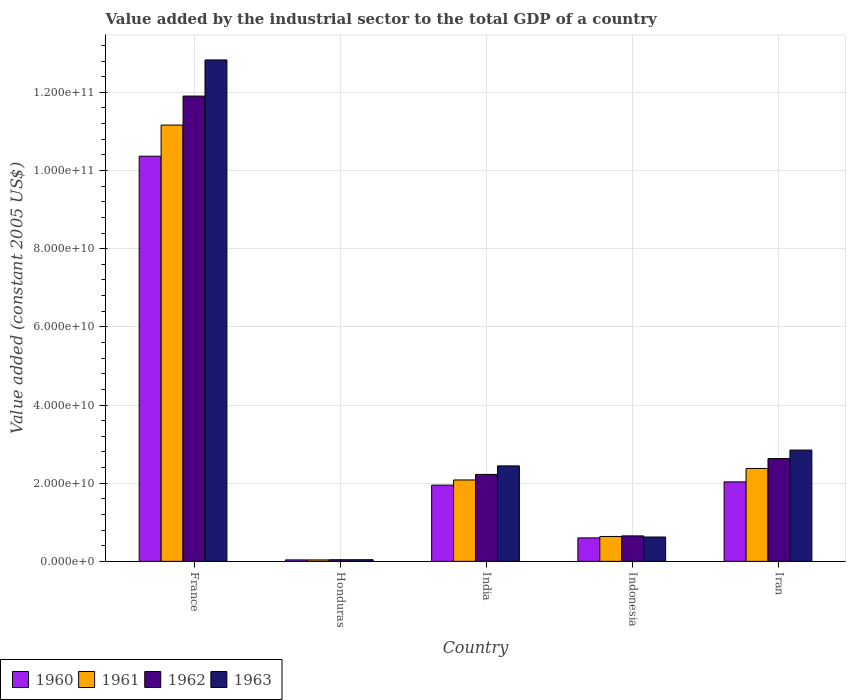How many bars are there on the 3rd tick from the left?
Your answer should be very brief. 4. What is the value added by the industrial sector in 1960 in Honduras?
Provide a short and direct response. 3.75e+08. Across all countries, what is the maximum value added by the industrial sector in 1963?
Provide a short and direct response. 1.28e+11. Across all countries, what is the minimum value added by the industrial sector in 1962?
Provide a short and direct response. 4.16e+08. In which country was the value added by the industrial sector in 1960 minimum?
Offer a very short reply. Honduras. What is the total value added by the industrial sector in 1961 in the graph?
Provide a short and direct response. 1.63e+11. What is the difference between the value added by the industrial sector in 1960 in Honduras and that in Iran?
Keep it short and to the point. -2.00e+1. What is the difference between the value added by the industrial sector in 1963 in Honduras and the value added by the industrial sector in 1960 in Indonesia?
Offer a very short reply. -5.58e+09. What is the average value added by the industrial sector in 1962 per country?
Give a very brief answer. 3.49e+1. What is the difference between the value added by the industrial sector of/in 1960 and value added by the industrial sector of/in 1962 in Iran?
Provide a succinct answer. -5.96e+09. In how many countries, is the value added by the industrial sector in 1960 greater than 12000000000 US$?
Keep it short and to the point. 3. What is the ratio of the value added by the industrial sector in 1961 in Honduras to that in India?
Your answer should be very brief. 0.02. Is the difference between the value added by the industrial sector in 1960 in India and Iran greater than the difference between the value added by the industrial sector in 1962 in India and Iran?
Offer a very short reply. Yes. What is the difference between the highest and the second highest value added by the industrial sector in 1960?
Your response must be concise. 8.33e+1. What is the difference between the highest and the lowest value added by the industrial sector in 1961?
Offer a terse response. 1.11e+11. Is the sum of the value added by the industrial sector in 1961 in France and Honduras greater than the maximum value added by the industrial sector in 1962 across all countries?
Your answer should be very brief. No. Is it the case that in every country, the sum of the value added by the industrial sector in 1960 and value added by the industrial sector in 1963 is greater than the value added by the industrial sector in 1962?
Your response must be concise. Yes. How many bars are there?
Give a very brief answer. 20. What is the difference between two consecutive major ticks on the Y-axis?
Ensure brevity in your answer.  2.00e+1. Does the graph contain any zero values?
Provide a succinct answer. No. Where does the legend appear in the graph?
Offer a terse response. Bottom left. How many legend labels are there?
Provide a succinct answer. 4. What is the title of the graph?
Your answer should be very brief. Value added by the industrial sector to the total GDP of a country. Does "1981" appear as one of the legend labels in the graph?
Make the answer very short. No. What is the label or title of the X-axis?
Offer a terse response. Country. What is the label or title of the Y-axis?
Keep it short and to the point. Value added (constant 2005 US$). What is the Value added (constant 2005 US$) in 1960 in France?
Make the answer very short. 1.04e+11. What is the Value added (constant 2005 US$) in 1961 in France?
Your response must be concise. 1.12e+11. What is the Value added (constant 2005 US$) in 1962 in France?
Provide a succinct answer. 1.19e+11. What is the Value added (constant 2005 US$) in 1963 in France?
Make the answer very short. 1.28e+11. What is the Value added (constant 2005 US$) of 1960 in Honduras?
Ensure brevity in your answer.  3.75e+08. What is the Value added (constant 2005 US$) in 1961 in Honduras?
Your response must be concise. 3.66e+08. What is the Value added (constant 2005 US$) of 1962 in Honduras?
Keep it short and to the point. 4.16e+08. What is the Value added (constant 2005 US$) in 1963 in Honduras?
Provide a succinct answer. 4.23e+08. What is the Value added (constant 2005 US$) in 1960 in India?
Provide a succinct answer. 1.95e+1. What is the Value added (constant 2005 US$) of 1961 in India?
Your answer should be very brief. 2.08e+1. What is the Value added (constant 2005 US$) in 1962 in India?
Your response must be concise. 2.22e+1. What is the Value added (constant 2005 US$) of 1963 in India?
Your answer should be compact. 2.44e+1. What is the Value added (constant 2005 US$) in 1960 in Indonesia?
Your response must be concise. 6.01e+09. What is the Value added (constant 2005 US$) in 1961 in Indonesia?
Provide a short and direct response. 6.37e+09. What is the Value added (constant 2005 US$) in 1962 in Indonesia?
Give a very brief answer. 6.52e+09. What is the Value added (constant 2005 US$) in 1963 in Indonesia?
Ensure brevity in your answer.  6.23e+09. What is the Value added (constant 2005 US$) of 1960 in Iran?
Offer a terse response. 2.03e+1. What is the Value added (constant 2005 US$) of 1961 in Iran?
Your answer should be compact. 2.38e+1. What is the Value added (constant 2005 US$) in 1962 in Iran?
Keep it short and to the point. 2.63e+1. What is the Value added (constant 2005 US$) of 1963 in Iran?
Keep it short and to the point. 2.85e+1. Across all countries, what is the maximum Value added (constant 2005 US$) of 1960?
Ensure brevity in your answer.  1.04e+11. Across all countries, what is the maximum Value added (constant 2005 US$) of 1961?
Provide a succinct answer. 1.12e+11. Across all countries, what is the maximum Value added (constant 2005 US$) in 1962?
Offer a terse response. 1.19e+11. Across all countries, what is the maximum Value added (constant 2005 US$) in 1963?
Give a very brief answer. 1.28e+11. Across all countries, what is the minimum Value added (constant 2005 US$) in 1960?
Your answer should be very brief. 3.75e+08. Across all countries, what is the minimum Value added (constant 2005 US$) of 1961?
Provide a succinct answer. 3.66e+08. Across all countries, what is the minimum Value added (constant 2005 US$) of 1962?
Offer a very short reply. 4.16e+08. Across all countries, what is the minimum Value added (constant 2005 US$) of 1963?
Your answer should be very brief. 4.23e+08. What is the total Value added (constant 2005 US$) in 1960 in the graph?
Make the answer very short. 1.50e+11. What is the total Value added (constant 2005 US$) in 1961 in the graph?
Ensure brevity in your answer.  1.63e+11. What is the total Value added (constant 2005 US$) of 1962 in the graph?
Provide a short and direct response. 1.75e+11. What is the total Value added (constant 2005 US$) of 1963 in the graph?
Provide a short and direct response. 1.88e+11. What is the difference between the Value added (constant 2005 US$) of 1960 in France and that in Honduras?
Offer a terse response. 1.03e+11. What is the difference between the Value added (constant 2005 US$) of 1961 in France and that in Honduras?
Your response must be concise. 1.11e+11. What is the difference between the Value added (constant 2005 US$) in 1962 in France and that in Honduras?
Your answer should be very brief. 1.19e+11. What is the difference between the Value added (constant 2005 US$) in 1963 in France and that in Honduras?
Provide a short and direct response. 1.28e+11. What is the difference between the Value added (constant 2005 US$) of 1960 in France and that in India?
Offer a very short reply. 8.42e+1. What is the difference between the Value added (constant 2005 US$) of 1961 in France and that in India?
Your answer should be compact. 9.08e+1. What is the difference between the Value added (constant 2005 US$) of 1962 in France and that in India?
Offer a very short reply. 9.68e+1. What is the difference between the Value added (constant 2005 US$) in 1963 in France and that in India?
Ensure brevity in your answer.  1.04e+11. What is the difference between the Value added (constant 2005 US$) of 1960 in France and that in Indonesia?
Your answer should be compact. 9.77e+1. What is the difference between the Value added (constant 2005 US$) of 1961 in France and that in Indonesia?
Give a very brief answer. 1.05e+11. What is the difference between the Value added (constant 2005 US$) of 1962 in France and that in Indonesia?
Your answer should be compact. 1.13e+11. What is the difference between the Value added (constant 2005 US$) of 1963 in France and that in Indonesia?
Your answer should be compact. 1.22e+11. What is the difference between the Value added (constant 2005 US$) of 1960 in France and that in Iran?
Provide a succinct answer. 8.33e+1. What is the difference between the Value added (constant 2005 US$) of 1961 in France and that in Iran?
Offer a very short reply. 8.79e+1. What is the difference between the Value added (constant 2005 US$) of 1962 in France and that in Iran?
Your response must be concise. 9.27e+1. What is the difference between the Value added (constant 2005 US$) in 1963 in France and that in Iran?
Ensure brevity in your answer.  9.98e+1. What is the difference between the Value added (constant 2005 US$) of 1960 in Honduras and that in India?
Ensure brevity in your answer.  -1.91e+1. What is the difference between the Value added (constant 2005 US$) of 1961 in Honduras and that in India?
Keep it short and to the point. -2.05e+1. What is the difference between the Value added (constant 2005 US$) in 1962 in Honduras and that in India?
Make the answer very short. -2.18e+1. What is the difference between the Value added (constant 2005 US$) in 1963 in Honduras and that in India?
Give a very brief answer. -2.40e+1. What is the difference between the Value added (constant 2005 US$) in 1960 in Honduras and that in Indonesia?
Make the answer very short. -5.63e+09. What is the difference between the Value added (constant 2005 US$) of 1961 in Honduras and that in Indonesia?
Offer a very short reply. -6.00e+09. What is the difference between the Value added (constant 2005 US$) of 1962 in Honduras and that in Indonesia?
Your response must be concise. -6.10e+09. What is the difference between the Value added (constant 2005 US$) of 1963 in Honduras and that in Indonesia?
Make the answer very short. -5.81e+09. What is the difference between the Value added (constant 2005 US$) in 1960 in Honduras and that in Iran?
Offer a terse response. -2.00e+1. What is the difference between the Value added (constant 2005 US$) of 1961 in Honduras and that in Iran?
Your response must be concise. -2.34e+1. What is the difference between the Value added (constant 2005 US$) of 1962 in Honduras and that in Iran?
Your answer should be very brief. -2.59e+1. What is the difference between the Value added (constant 2005 US$) of 1963 in Honduras and that in Iran?
Offer a terse response. -2.81e+1. What is the difference between the Value added (constant 2005 US$) in 1960 in India and that in Indonesia?
Your response must be concise. 1.35e+1. What is the difference between the Value added (constant 2005 US$) of 1961 in India and that in Indonesia?
Your answer should be very brief. 1.45e+1. What is the difference between the Value added (constant 2005 US$) in 1962 in India and that in Indonesia?
Give a very brief answer. 1.57e+1. What is the difference between the Value added (constant 2005 US$) in 1963 in India and that in Indonesia?
Provide a short and direct response. 1.82e+1. What is the difference between the Value added (constant 2005 US$) in 1960 in India and that in Iran?
Offer a terse response. -8.36e+08. What is the difference between the Value added (constant 2005 US$) of 1961 in India and that in Iran?
Offer a very short reply. -2.94e+09. What is the difference between the Value added (constant 2005 US$) of 1962 in India and that in Iran?
Offer a very short reply. -4.06e+09. What is the difference between the Value added (constant 2005 US$) in 1963 in India and that in Iran?
Offer a terse response. -4.05e+09. What is the difference between the Value added (constant 2005 US$) in 1960 in Indonesia and that in Iran?
Ensure brevity in your answer.  -1.43e+1. What is the difference between the Value added (constant 2005 US$) of 1961 in Indonesia and that in Iran?
Make the answer very short. -1.74e+1. What is the difference between the Value added (constant 2005 US$) in 1962 in Indonesia and that in Iran?
Keep it short and to the point. -1.98e+1. What is the difference between the Value added (constant 2005 US$) in 1963 in Indonesia and that in Iran?
Your answer should be compact. -2.22e+1. What is the difference between the Value added (constant 2005 US$) in 1960 in France and the Value added (constant 2005 US$) in 1961 in Honduras?
Give a very brief answer. 1.03e+11. What is the difference between the Value added (constant 2005 US$) of 1960 in France and the Value added (constant 2005 US$) of 1962 in Honduras?
Make the answer very short. 1.03e+11. What is the difference between the Value added (constant 2005 US$) of 1960 in France and the Value added (constant 2005 US$) of 1963 in Honduras?
Give a very brief answer. 1.03e+11. What is the difference between the Value added (constant 2005 US$) in 1961 in France and the Value added (constant 2005 US$) in 1962 in Honduras?
Your answer should be very brief. 1.11e+11. What is the difference between the Value added (constant 2005 US$) of 1961 in France and the Value added (constant 2005 US$) of 1963 in Honduras?
Provide a succinct answer. 1.11e+11. What is the difference between the Value added (constant 2005 US$) of 1962 in France and the Value added (constant 2005 US$) of 1963 in Honduras?
Your answer should be compact. 1.19e+11. What is the difference between the Value added (constant 2005 US$) of 1960 in France and the Value added (constant 2005 US$) of 1961 in India?
Provide a short and direct response. 8.28e+1. What is the difference between the Value added (constant 2005 US$) of 1960 in France and the Value added (constant 2005 US$) of 1962 in India?
Offer a terse response. 8.14e+1. What is the difference between the Value added (constant 2005 US$) in 1960 in France and the Value added (constant 2005 US$) in 1963 in India?
Keep it short and to the point. 7.92e+1. What is the difference between the Value added (constant 2005 US$) in 1961 in France and the Value added (constant 2005 US$) in 1962 in India?
Offer a very short reply. 8.94e+1. What is the difference between the Value added (constant 2005 US$) of 1961 in France and the Value added (constant 2005 US$) of 1963 in India?
Your answer should be compact. 8.72e+1. What is the difference between the Value added (constant 2005 US$) of 1962 in France and the Value added (constant 2005 US$) of 1963 in India?
Make the answer very short. 9.46e+1. What is the difference between the Value added (constant 2005 US$) of 1960 in France and the Value added (constant 2005 US$) of 1961 in Indonesia?
Your answer should be very brief. 9.73e+1. What is the difference between the Value added (constant 2005 US$) in 1960 in France and the Value added (constant 2005 US$) in 1962 in Indonesia?
Make the answer very short. 9.71e+1. What is the difference between the Value added (constant 2005 US$) of 1960 in France and the Value added (constant 2005 US$) of 1963 in Indonesia?
Give a very brief answer. 9.74e+1. What is the difference between the Value added (constant 2005 US$) of 1961 in France and the Value added (constant 2005 US$) of 1962 in Indonesia?
Provide a succinct answer. 1.05e+11. What is the difference between the Value added (constant 2005 US$) of 1961 in France and the Value added (constant 2005 US$) of 1963 in Indonesia?
Offer a very short reply. 1.05e+11. What is the difference between the Value added (constant 2005 US$) of 1962 in France and the Value added (constant 2005 US$) of 1963 in Indonesia?
Provide a succinct answer. 1.13e+11. What is the difference between the Value added (constant 2005 US$) in 1960 in France and the Value added (constant 2005 US$) in 1961 in Iran?
Ensure brevity in your answer.  7.99e+1. What is the difference between the Value added (constant 2005 US$) of 1960 in France and the Value added (constant 2005 US$) of 1962 in Iran?
Make the answer very short. 7.74e+1. What is the difference between the Value added (constant 2005 US$) in 1960 in France and the Value added (constant 2005 US$) in 1963 in Iran?
Offer a very short reply. 7.52e+1. What is the difference between the Value added (constant 2005 US$) of 1961 in France and the Value added (constant 2005 US$) of 1962 in Iran?
Your answer should be very brief. 8.53e+1. What is the difference between the Value added (constant 2005 US$) in 1961 in France and the Value added (constant 2005 US$) in 1963 in Iran?
Offer a very short reply. 8.32e+1. What is the difference between the Value added (constant 2005 US$) in 1962 in France and the Value added (constant 2005 US$) in 1963 in Iran?
Your response must be concise. 9.06e+1. What is the difference between the Value added (constant 2005 US$) of 1960 in Honduras and the Value added (constant 2005 US$) of 1961 in India?
Keep it short and to the point. -2.05e+1. What is the difference between the Value added (constant 2005 US$) in 1960 in Honduras and the Value added (constant 2005 US$) in 1962 in India?
Keep it short and to the point. -2.19e+1. What is the difference between the Value added (constant 2005 US$) in 1960 in Honduras and the Value added (constant 2005 US$) in 1963 in India?
Ensure brevity in your answer.  -2.41e+1. What is the difference between the Value added (constant 2005 US$) of 1961 in Honduras and the Value added (constant 2005 US$) of 1962 in India?
Give a very brief answer. -2.19e+1. What is the difference between the Value added (constant 2005 US$) of 1961 in Honduras and the Value added (constant 2005 US$) of 1963 in India?
Your answer should be very brief. -2.41e+1. What is the difference between the Value added (constant 2005 US$) of 1962 in Honduras and the Value added (constant 2005 US$) of 1963 in India?
Your answer should be very brief. -2.40e+1. What is the difference between the Value added (constant 2005 US$) in 1960 in Honduras and the Value added (constant 2005 US$) in 1961 in Indonesia?
Your response must be concise. -5.99e+09. What is the difference between the Value added (constant 2005 US$) in 1960 in Honduras and the Value added (constant 2005 US$) in 1962 in Indonesia?
Give a very brief answer. -6.14e+09. What is the difference between the Value added (constant 2005 US$) in 1960 in Honduras and the Value added (constant 2005 US$) in 1963 in Indonesia?
Give a very brief answer. -5.85e+09. What is the difference between the Value added (constant 2005 US$) in 1961 in Honduras and the Value added (constant 2005 US$) in 1962 in Indonesia?
Your answer should be compact. -6.15e+09. What is the difference between the Value added (constant 2005 US$) of 1961 in Honduras and the Value added (constant 2005 US$) of 1963 in Indonesia?
Make the answer very short. -5.86e+09. What is the difference between the Value added (constant 2005 US$) in 1962 in Honduras and the Value added (constant 2005 US$) in 1963 in Indonesia?
Ensure brevity in your answer.  -5.81e+09. What is the difference between the Value added (constant 2005 US$) in 1960 in Honduras and the Value added (constant 2005 US$) in 1961 in Iran?
Provide a short and direct response. -2.34e+1. What is the difference between the Value added (constant 2005 US$) of 1960 in Honduras and the Value added (constant 2005 US$) of 1962 in Iran?
Ensure brevity in your answer.  -2.59e+1. What is the difference between the Value added (constant 2005 US$) in 1960 in Honduras and the Value added (constant 2005 US$) in 1963 in Iran?
Make the answer very short. -2.81e+1. What is the difference between the Value added (constant 2005 US$) of 1961 in Honduras and the Value added (constant 2005 US$) of 1962 in Iran?
Ensure brevity in your answer.  -2.59e+1. What is the difference between the Value added (constant 2005 US$) in 1961 in Honduras and the Value added (constant 2005 US$) in 1963 in Iran?
Keep it short and to the point. -2.81e+1. What is the difference between the Value added (constant 2005 US$) in 1962 in Honduras and the Value added (constant 2005 US$) in 1963 in Iran?
Ensure brevity in your answer.  -2.81e+1. What is the difference between the Value added (constant 2005 US$) in 1960 in India and the Value added (constant 2005 US$) in 1961 in Indonesia?
Your answer should be very brief. 1.31e+1. What is the difference between the Value added (constant 2005 US$) of 1960 in India and the Value added (constant 2005 US$) of 1962 in Indonesia?
Ensure brevity in your answer.  1.30e+1. What is the difference between the Value added (constant 2005 US$) of 1960 in India and the Value added (constant 2005 US$) of 1963 in Indonesia?
Your answer should be very brief. 1.33e+1. What is the difference between the Value added (constant 2005 US$) of 1961 in India and the Value added (constant 2005 US$) of 1962 in Indonesia?
Offer a very short reply. 1.43e+1. What is the difference between the Value added (constant 2005 US$) in 1961 in India and the Value added (constant 2005 US$) in 1963 in Indonesia?
Your response must be concise. 1.46e+1. What is the difference between the Value added (constant 2005 US$) of 1962 in India and the Value added (constant 2005 US$) of 1963 in Indonesia?
Give a very brief answer. 1.60e+1. What is the difference between the Value added (constant 2005 US$) of 1960 in India and the Value added (constant 2005 US$) of 1961 in Iran?
Provide a short and direct response. -4.27e+09. What is the difference between the Value added (constant 2005 US$) of 1960 in India and the Value added (constant 2005 US$) of 1962 in Iran?
Provide a short and direct response. -6.80e+09. What is the difference between the Value added (constant 2005 US$) of 1960 in India and the Value added (constant 2005 US$) of 1963 in Iran?
Your answer should be compact. -8.97e+09. What is the difference between the Value added (constant 2005 US$) of 1961 in India and the Value added (constant 2005 US$) of 1962 in Iran?
Your answer should be compact. -5.48e+09. What is the difference between the Value added (constant 2005 US$) of 1961 in India and the Value added (constant 2005 US$) of 1963 in Iran?
Provide a short and direct response. -7.65e+09. What is the difference between the Value added (constant 2005 US$) in 1962 in India and the Value added (constant 2005 US$) in 1963 in Iran?
Your answer should be very brief. -6.23e+09. What is the difference between the Value added (constant 2005 US$) in 1960 in Indonesia and the Value added (constant 2005 US$) in 1961 in Iran?
Offer a terse response. -1.78e+1. What is the difference between the Value added (constant 2005 US$) in 1960 in Indonesia and the Value added (constant 2005 US$) in 1962 in Iran?
Your answer should be very brief. -2.03e+1. What is the difference between the Value added (constant 2005 US$) of 1960 in Indonesia and the Value added (constant 2005 US$) of 1963 in Iran?
Make the answer very short. -2.25e+1. What is the difference between the Value added (constant 2005 US$) in 1961 in Indonesia and the Value added (constant 2005 US$) in 1962 in Iran?
Offer a very short reply. -1.99e+1. What is the difference between the Value added (constant 2005 US$) in 1961 in Indonesia and the Value added (constant 2005 US$) in 1963 in Iran?
Keep it short and to the point. -2.21e+1. What is the difference between the Value added (constant 2005 US$) in 1962 in Indonesia and the Value added (constant 2005 US$) in 1963 in Iran?
Give a very brief answer. -2.20e+1. What is the average Value added (constant 2005 US$) of 1960 per country?
Offer a very short reply. 3.00e+1. What is the average Value added (constant 2005 US$) in 1961 per country?
Make the answer very short. 3.26e+1. What is the average Value added (constant 2005 US$) of 1962 per country?
Your answer should be very brief. 3.49e+1. What is the average Value added (constant 2005 US$) of 1963 per country?
Provide a short and direct response. 3.76e+1. What is the difference between the Value added (constant 2005 US$) in 1960 and Value added (constant 2005 US$) in 1961 in France?
Offer a terse response. -7.97e+09. What is the difference between the Value added (constant 2005 US$) of 1960 and Value added (constant 2005 US$) of 1962 in France?
Offer a very short reply. -1.54e+1. What is the difference between the Value added (constant 2005 US$) in 1960 and Value added (constant 2005 US$) in 1963 in France?
Keep it short and to the point. -2.46e+1. What is the difference between the Value added (constant 2005 US$) of 1961 and Value added (constant 2005 US$) of 1962 in France?
Ensure brevity in your answer.  -7.41e+09. What is the difference between the Value added (constant 2005 US$) in 1961 and Value added (constant 2005 US$) in 1963 in France?
Make the answer very short. -1.67e+1. What is the difference between the Value added (constant 2005 US$) in 1962 and Value added (constant 2005 US$) in 1963 in France?
Provide a short and direct response. -9.25e+09. What is the difference between the Value added (constant 2005 US$) of 1960 and Value added (constant 2005 US$) of 1961 in Honduras?
Provide a succinct answer. 9.37e+06. What is the difference between the Value added (constant 2005 US$) of 1960 and Value added (constant 2005 US$) of 1962 in Honduras?
Your answer should be very brief. -4.07e+07. What is the difference between the Value added (constant 2005 US$) of 1960 and Value added (constant 2005 US$) of 1963 in Honduras?
Keep it short and to the point. -4.79e+07. What is the difference between the Value added (constant 2005 US$) of 1961 and Value added (constant 2005 US$) of 1962 in Honduras?
Provide a succinct answer. -5.00e+07. What is the difference between the Value added (constant 2005 US$) of 1961 and Value added (constant 2005 US$) of 1963 in Honduras?
Offer a very short reply. -5.72e+07. What is the difference between the Value added (constant 2005 US$) of 1962 and Value added (constant 2005 US$) of 1963 in Honduras?
Keep it short and to the point. -7.19e+06. What is the difference between the Value added (constant 2005 US$) in 1960 and Value added (constant 2005 US$) in 1961 in India?
Your answer should be very brief. -1.32e+09. What is the difference between the Value added (constant 2005 US$) in 1960 and Value added (constant 2005 US$) in 1962 in India?
Offer a terse response. -2.74e+09. What is the difference between the Value added (constant 2005 US$) of 1960 and Value added (constant 2005 US$) of 1963 in India?
Keep it short and to the point. -4.92e+09. What is the difference between the Value added (constant 2005 US$) in 1961 and Value added (constant 2005 US$) in 1962 in India?
Keep it short and to the point. -1.42e+09. What is the difference between the Value added (constant 2005 US$) of 1961 and Value added (constant 2005 US$) of 1963 in India?
Your answer should be very brief. -3.60e+09. What is the difference between the Value added (constant 2005 US$) in 1962 and Value added (constant 2005 US$) in 1963 in India?
Offer a very short reply. -2.18e+09. What is the difference between the Value added (constant 2005 US$) in 1960 and Value added (constant 2005 US$) in 1961 in Indonesia?
Offer a very short reply. -3.60e+08. What is the difference between the Value added (constant 2005 US$) in 1960 and Value added (constant 2005 US$) in 1962 in Indonesia?
Offer a very short reply. -5.10e+08. What is the difference between the Value added (constant 2005 US$) of 1960 and Value added (constant 2005 US$) of 1963 in Indonesia?
Keep it short and to the point. -2.22e+08. What is the difference between the Value added (constant 2005 US$) in 1961 and Value added (constant 2005 US$) in 1962 in Indonesia?
Offer a terse response. -1.50e+08. What is the difference between the Value added (constant 2005 US$) of 1961 and Value added (constant 2005 US$) of 1963 in Indonesia?
Your answer should be very brief. 1.38e+08. What is the difference between the Value added (constant 2005 US$) in 1962 and Value added (constant 2005 US$) in 1963 in Indonesia?
Your answer should be very brief. 2.88e+08. What is the difference between the Value added (constant 2005 US$) in 1960 and Value added (constant 2005 US$) in 1961 in Iran?
Your answer should be compact. -3.43e+09. What is the difference between the Value added (constant 2005 US$) of 1960 and Value added (constant 2005 US$) of 1962 in Iran?
Your response must be concise. -5.96e+09. What is the difference between the Value added (constant 2005 US$) in 1960 and Value added (constant 2005 US$) in 1963 in Iran?
Your answer should be very brief. -8.14e+09. What is the difference between the Value added (constant 2005 US$) in 1961 and Value added (constant 2005 US$) in 1962 in Iran?
Give a very brief answer. -2.53e+09. What is the difference between the Value added (constant 2005 US$) in 1961 and Value added (constant 2005 US$) in 1963 in Iran?
Your answer should be very brief. -4.71e+09. What is the difference between the Value added (constant 2005 US$) of 1962 and Value added (constant 2005 US$) of 1963 in Iran?
Offer a very short reply. -2.17e+09. What is the ratio of the Value added (constant 2005 US$) in 1960 in France to that in Honduras?
Offer a terse response. 276.31. What is the ratio of the Value added (constant 2005 US$) in 1961 in France to that in Honduras?
Offer a terse response. 305.16. What is the ratio of the Value added (constant 2005 US$) of 1962 in France to that in Honduras?
Provide a succinct answer. 286.26. What is the ratio of the Value added (constant 2005 US$) in 1963 in France to that in Honduras?
Offer a very short reply. 303.25. What is the ratio of the Value added (constant 2005 US$) of 1960 in France to that in India?
Offer a very short reply. 5.32. What is the ratio of the Value added (constant 2005 US$) in 1961 in France to that in India?
Give a very brief answer. 5.36. What is the ratio of the Value added (constant 2005 US$) of 1962 in France to that in India?
Provide a succinct answer. 5.35. What is the ratio of the Value added (constant 2005 US$) of 1963 in France to that in India?
Keep it short and to the point. 5.25. What is the ratio of the Value added (constant 2005 US$) of 1960 in France to that in Indonesia?
Your response must be concise. 17.26. What is the ratio of the Value added (constant 2005 US$) in 1961 in France to that in Indonesia?
Make the answer very short. 17.53. What is the ratio of the Value added (constant 2005 US$) of 1962 in France to that in Indonesia?
Provide a short and direct response. 18.27. What is the ratio of the Value added (constant 2005 US$) of 1963 in France to that in Indonesia?
Your answer should be compact. 20.59. What is the ratio of the Value added (constant 2005 US$) of 1960 in France to that in Iran?
Your response must be concise. 5.1. What is the ratio of the Value added (constant 2005 US$) in 1961 in France to that in Iran?
Give a very brief answer. 4.7. What is the ratio of the Value added (constant 2005 US$) in 1962 in France to that in Iran?
Keep it short and to the point. 4.53. What is the ratio of the Value added (constant 2005 US$) of 1963 in France to that in Iran?
Give a very brief answer. 4.51. What is the ratio of the Value added (constant 2005 US$) in 1960 in Honduras to that in India?
Your response must be concise. 0.02. What is the ratio of the Value added (constant 2005 US$) in 1961 in Honduras to that in India?
Give a very brief answer. 0.02. What is the ratio of the Value added (constant 2005 US$) in 1962 in Honduras to that in India?
Your answer should be very brief. 0.02. What is the ratio of the Value added (constant 2005 US$) in 1963 in Honduras to that in India?
Make the answer very short. 0.02. What is the ratio of the Value added (constant 2005 US$) in 1960 in Honduras to that in Indonesia?
Make the answer very short. 0.06. What is the ratio of the Value added (constant 2005 US$) of 1961 in Honduras to that in Indonesia?
Provide a succinct answer. 0.06. What is the ratio of the Value added (constant 2005 US$) in 1962 in Honduras to that in Indonesia?
Give a very brief answer. 0.06. What is the ratio of the Value added (constant 2005 US$) of 1963 in Honduras to that in Indonesia?
Make the answer very short. 0.07. What is the ratio of the Value added (constant 2005 US$) in 1960 in Honduras to that in Iran?
Provide a succinct answer. 0.02. What is the ratio of the Value added (constant 2005 US$) of 1961 in Honduras to that in Iran?
Ensure brevity in your answer.  0.02. What is the ratio of the Value added (constant 2005 US$) of 1962 in Honduras to that in Iran?
Your response must be concise. 0.02. What is the ratio of the Value added (constant 2005 US$) of 1963 in Honduras to that in Iran?
Make the answer very short. 0.01. What is the ratio of the Value added (constant 2005 US$) of 1960 in India to that in Indonesia?
Offer a very short reply. 3.25. What is the ratio of the Value added (constant 2005 US$) in 1961 in India to that in Indonesia?
Provide a succinct answer. 3.27. What is the ratio of the Value added (constant 2005 US$) of 1962 in India to that in Indonesia?
Make the answer very short. 3.41. What is the ratio of the Value added (constant 2005 US$) in 1963 in India to that in Indonesia?
Provide a succinct answer. 3.92. What is the ratio of the Value added (constant 2005 US$) of 1960 in India to that in Iran?
Give a very brief answer. 0.96. What is the ratio of the Value added (constant 2005 US$) of 1961 in India to that in Iran?
Your answer should be very brief. 0.88. What is the ratio of the Value added (constant 2005 US$) of 1962 in India to that in Iran?
Keep it short and to the point. 0.85. What is the ratio of the Value added (constant 2005 US$) of 1963 in India to that in Iran?
Your answer should be compact. 0.86. What is the ratio of the Value added (constant 2005 US$) in 1960 in Indonesia to that in Iran?
Keep it short and to the point. 0.3. What is the ratio of the Value added (constant 2005 US$) in 1961 in Indonesia to that in Iran?
Make the answer very short. 0.27. What is the ratio of the Value added (constant 2005 US$) in 1962 in Indonesia to that in Iran?
Offer a terse response. 0.25. What is the ratio of the Value added (constant 2005 US$) of 1963 in Indonesia to that in Iran?
Keep it short and to the point. 0.22. What is the difference between the highest and the second highest Value added (constant 2005 US$) of 1960?
Your answer should be compact. 8.33e+1. What is the difference between the highest and the second highest Value added (constant 2005 US$) in 1961?
Your response must be concise. 8.79e+1. What is the difference between the highest and the second highest Value added (constant 2005 US$) in 1962?
Keep it short and to the point. 9.27e+1. What is the difference between the highest and the second highest Value added (constant 2005 US$) in 1963?
Offer a very short reply. 9.98e+1. What is the difference between the highest and the lowest Value added (constant 2005 US$) in 1960?
Your answer should be very brief. 1.03e+11. What is the difference between the highest and the lowest Value added (constant 2005 US$) in 1961?
Your answer should be compact. 1.11e+11. What is the difference between the highest and the lowest Value added (constant 2005 US$) of 1962?
Offer a very short reply. 1.19e+11. What is the difference between the highest and the lowest Value added (constant 2005 US$) of 1963?
Offer a very short reply. 1.28e+11. 